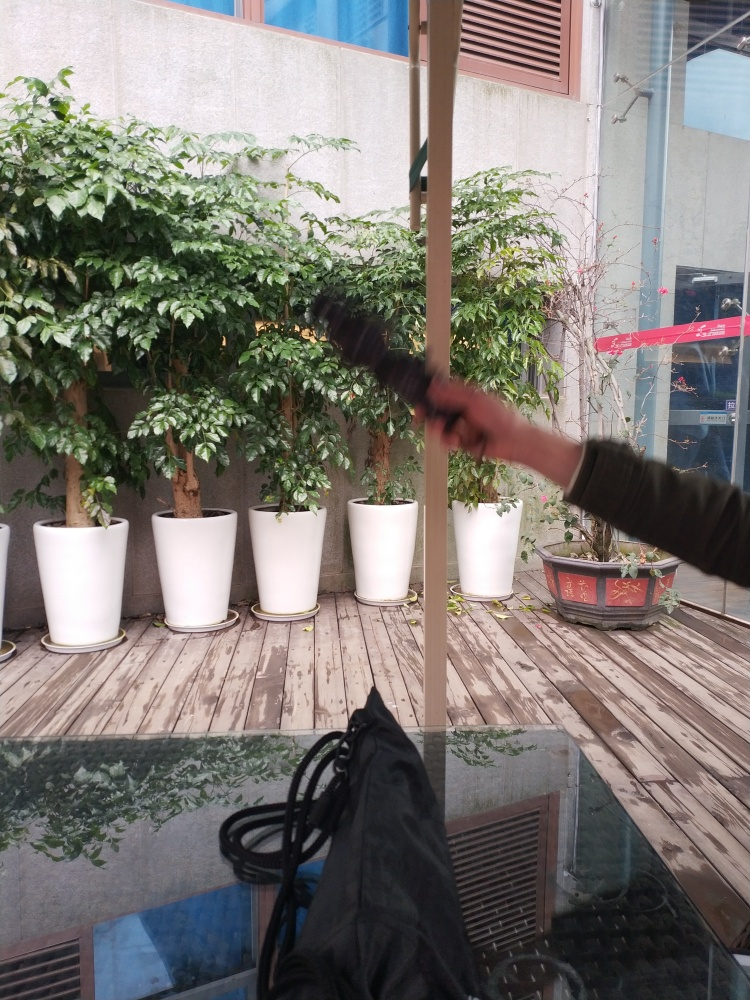Are there any focusing issues in the image?
A. No
B. Quite a few
C. Yes
D. Unclear
Answer with the option's letter from the given choices directly.
 A. 